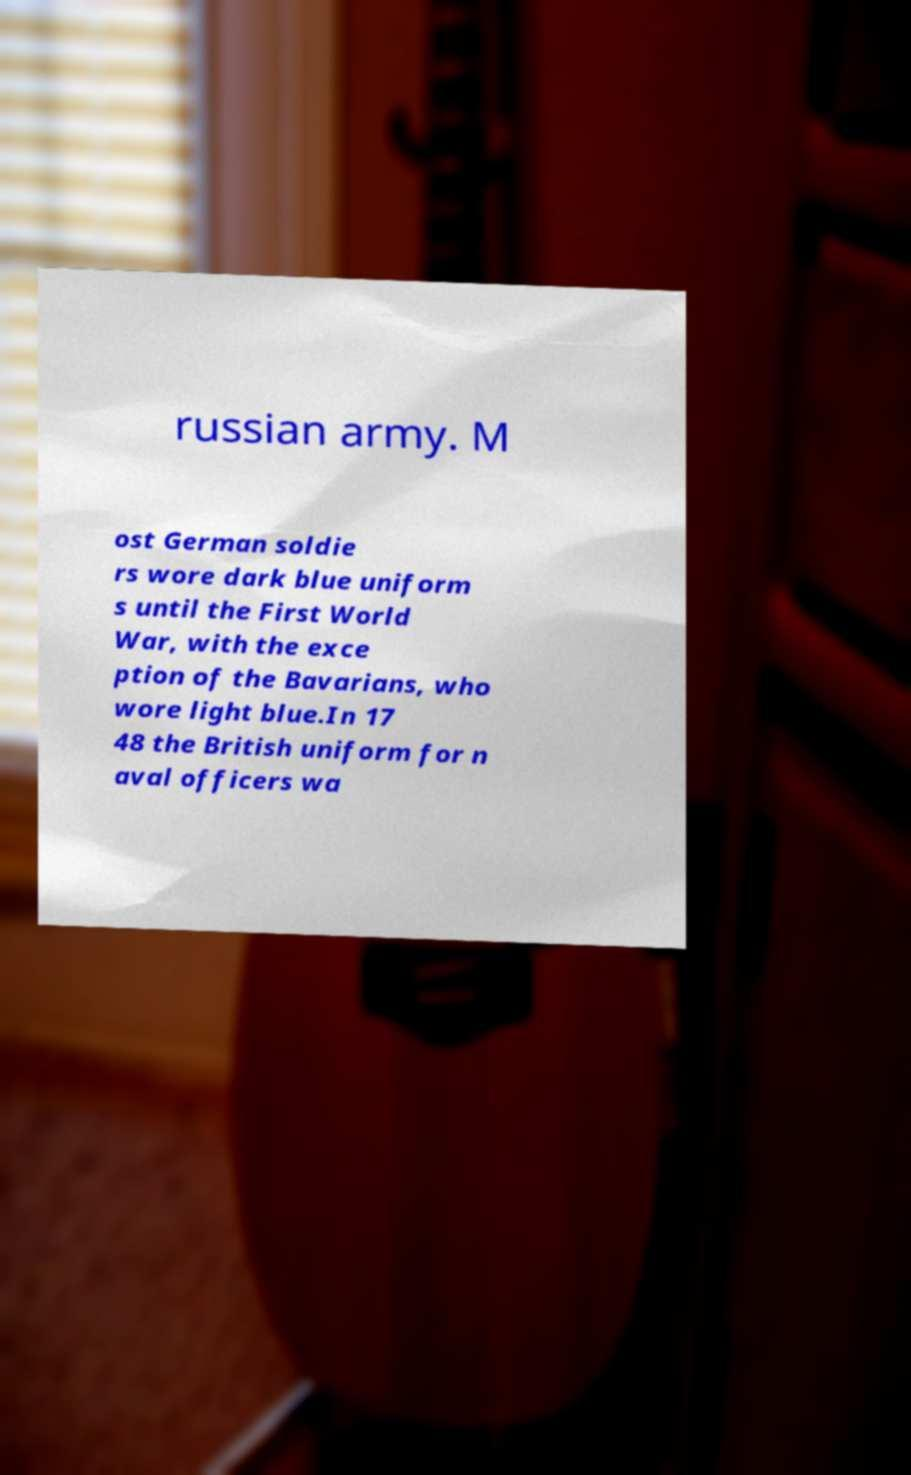Could you assist in decoding the text presented in this image and type it out clearly? russian army. M ost German soldie rs wore dark blue uniform s until the First World War, with the exce ption of the Bavarians, who wore light blue.In 17 48 the British uniform for n aval officers wa 